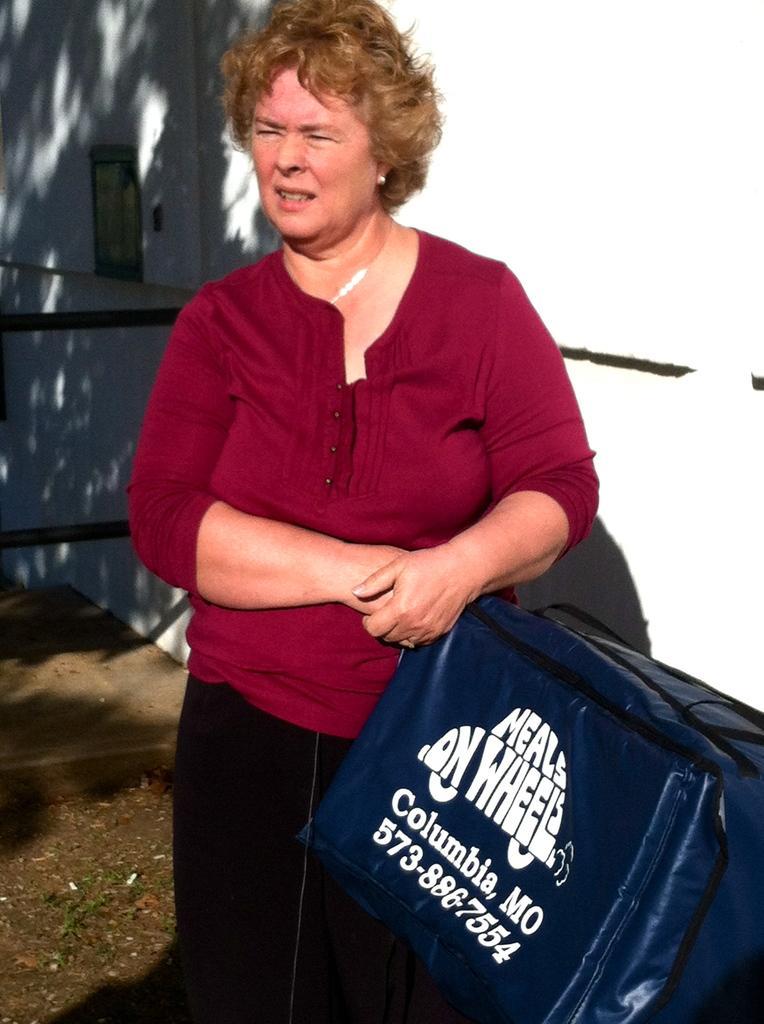In one or two sentences, can you explain what this image depicts? In this picture I can see a woman holding bag, behind we can see the wall. 